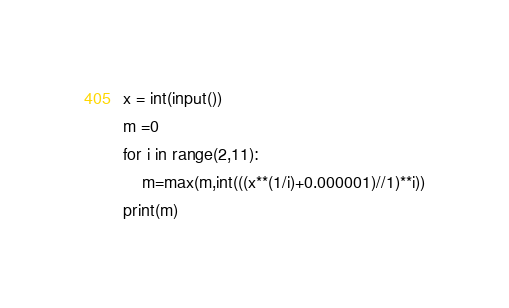<code> <loc_0><loc_0><loc_500><loc_500><_Python_>x = int(input())
m =0
for i in range(2,11):
    m=max(m,int(((x**(1/i)+0.000001)//1)**i))
print(m)
</code> 